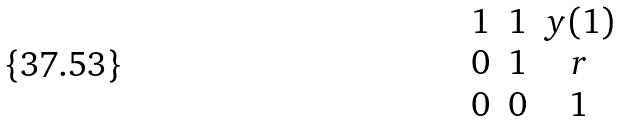<formula> <loc_0><loc_0><loc_500><loc_500>\begin{matrix} 1 & 1 & y ( 1 ) \\ 0 & 1 & r \\ 0 & 0 & 1 \end{matrix}</formula> 